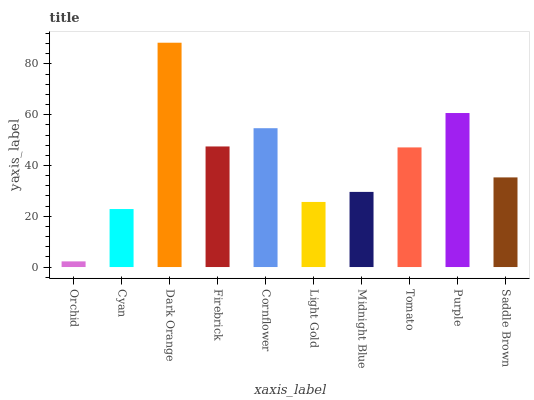Is Orchid the minimum?
Answer yes or no. Yes. Is Dark Orange the maximum?
Answer yes or no. Yes. Is Cyan the minimum?
Answer yes or no. No. Is Cyan the maximum?
Answer yes or no. No. Is Cyan greater than Orchid?
Answer yes or no. Yes. Is Orchid less than Cyan?
Answer yes or no. Yes. Is Orchid greater than Cyan?
Answer yes or no. No. Is Cyan less than Orchid?
Answer yes or no. No. Is Tomato the high median?
Answer yes or no. Yes. Is Saddle Brown the low median?
Answer yes or no. Yes. Is Orchid the high median?
Answer yes or no. No. Is Tomato the low median?
Answer yes or no. No. 